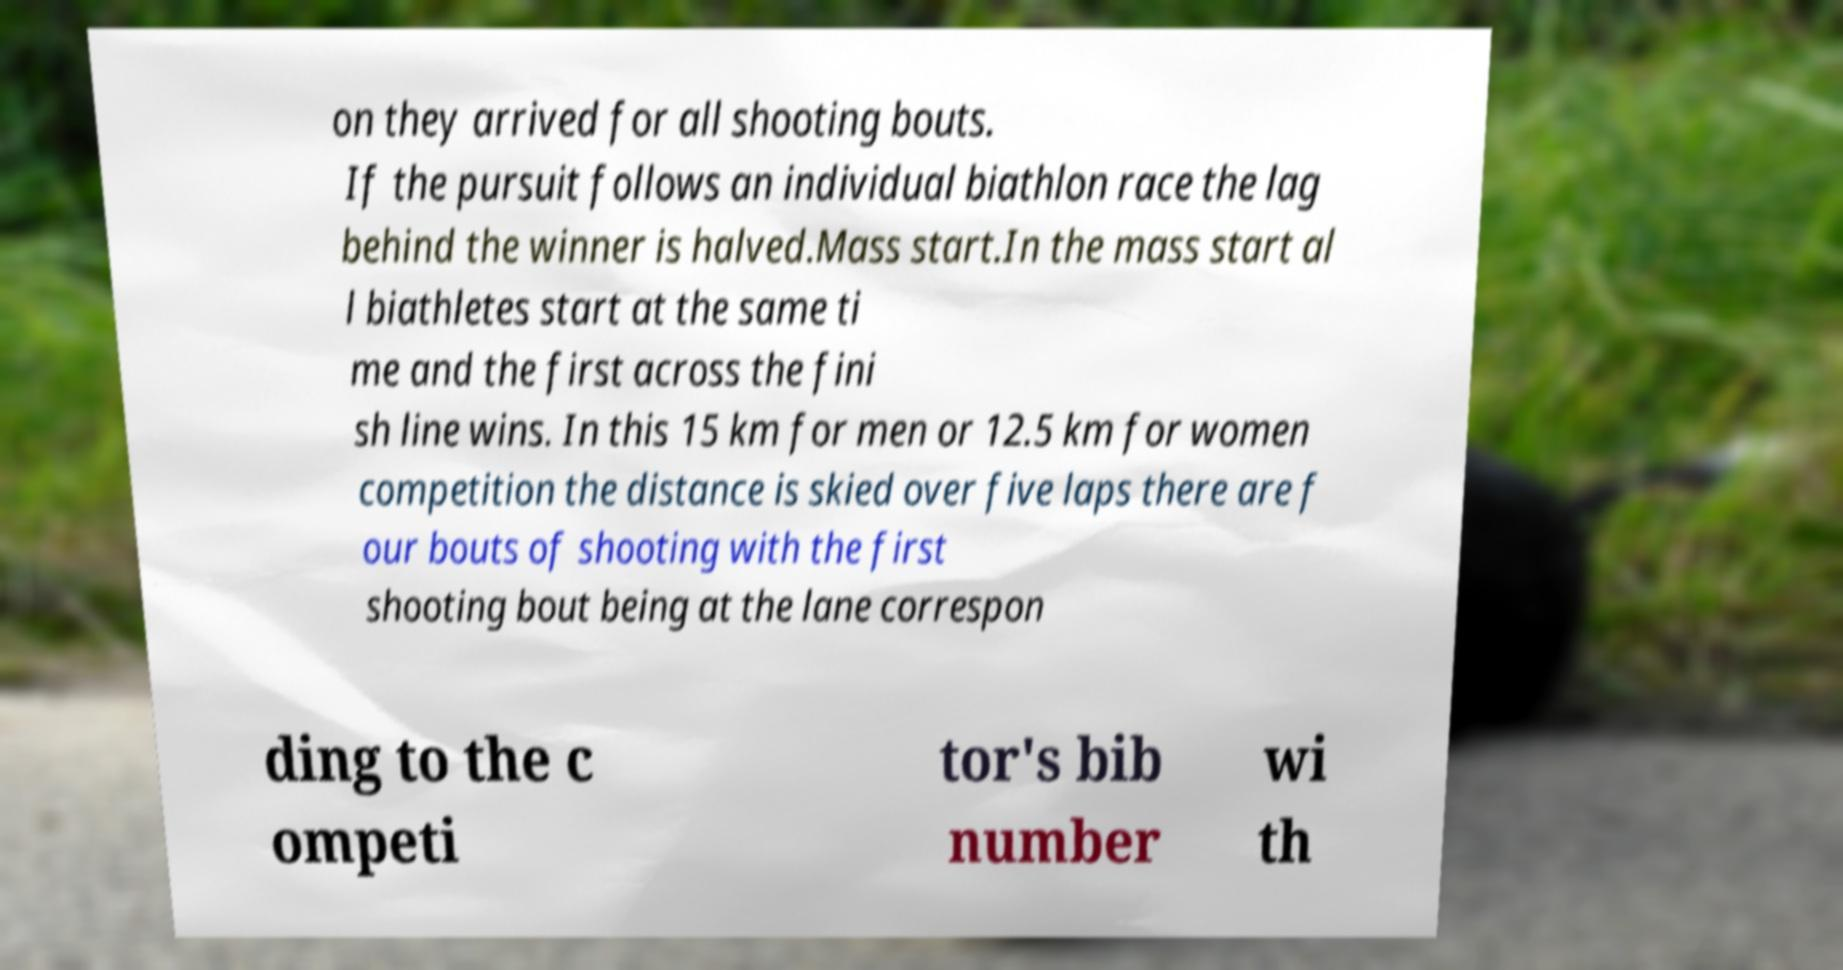Can you read and provide the text displayed in the image?This photo seems to have some interesting text. Can you extract and type it out for me? on they arrived for all shooting bouts. If the pursuit follows an individual biathlon race the lag behind the winner is halved.Mass start.In the mass start al l biathletes start at the same ti me and the first across the fini sh line wins. In this 15 km for men or 12.5 km for women competition the distance is skied over five laps there are f our bouts of shooting with the first shooting bout being at the lane correspon ding to the c ompeti tor's bib number wi th 